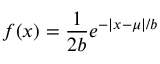Convert formula to latex. <formula><loc_0><loc_0><loc_500><loc_500>f ( x ) = { \frac { 1 } { 2 b } } e ^ { - | x - \mu | / b }</formula> 